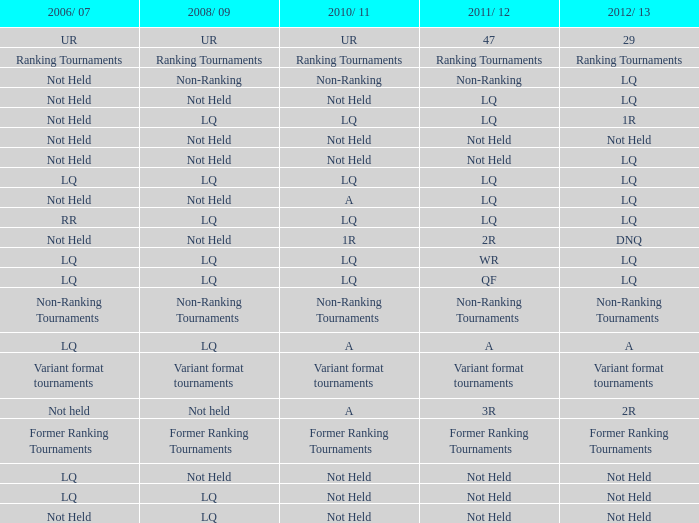What does 2006/07 represent, when 2008/09 stands for lq, when 2012/13 signifies lq, and when 2011/12 denotes wr? LQ. 